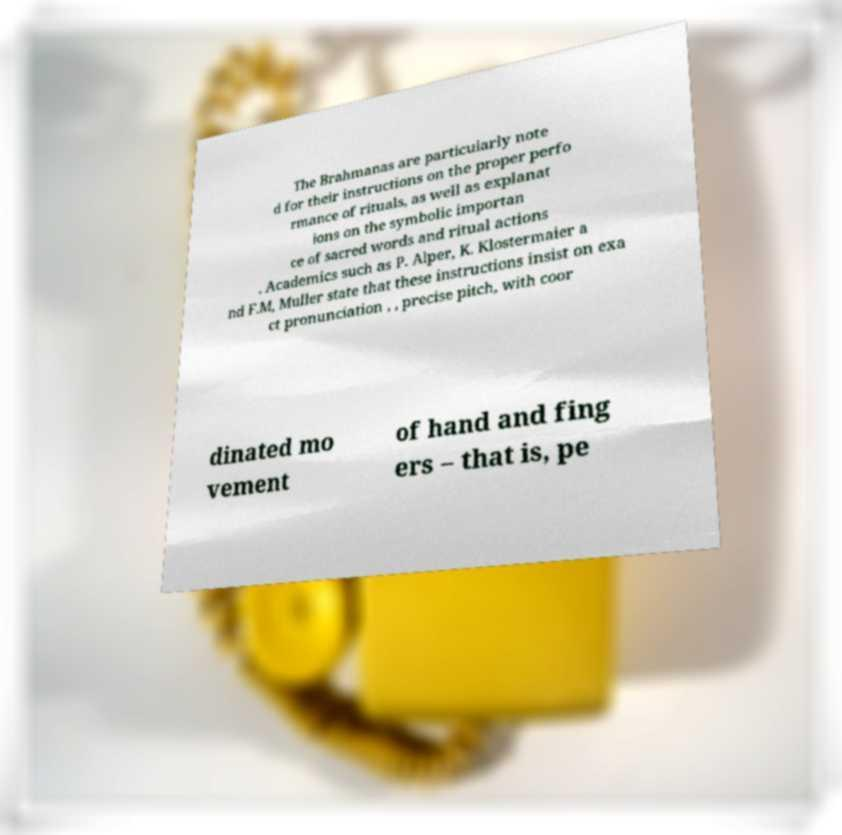Please read and relay the text visible in this image. What does it say? The Brahmanas are particularly note d for their instructions on the proper perfo rmance of rituals, as well as explanat ions on the symbolic importan ce of sacred words and ritual actions . Academics such as P. Alper, K. Klostermaier a nd F.M, Muller state that these instructions insist on exa ct pronunciation , , precise pitch, with coor dinated mo vement of hand and fing ers – that is, pe 